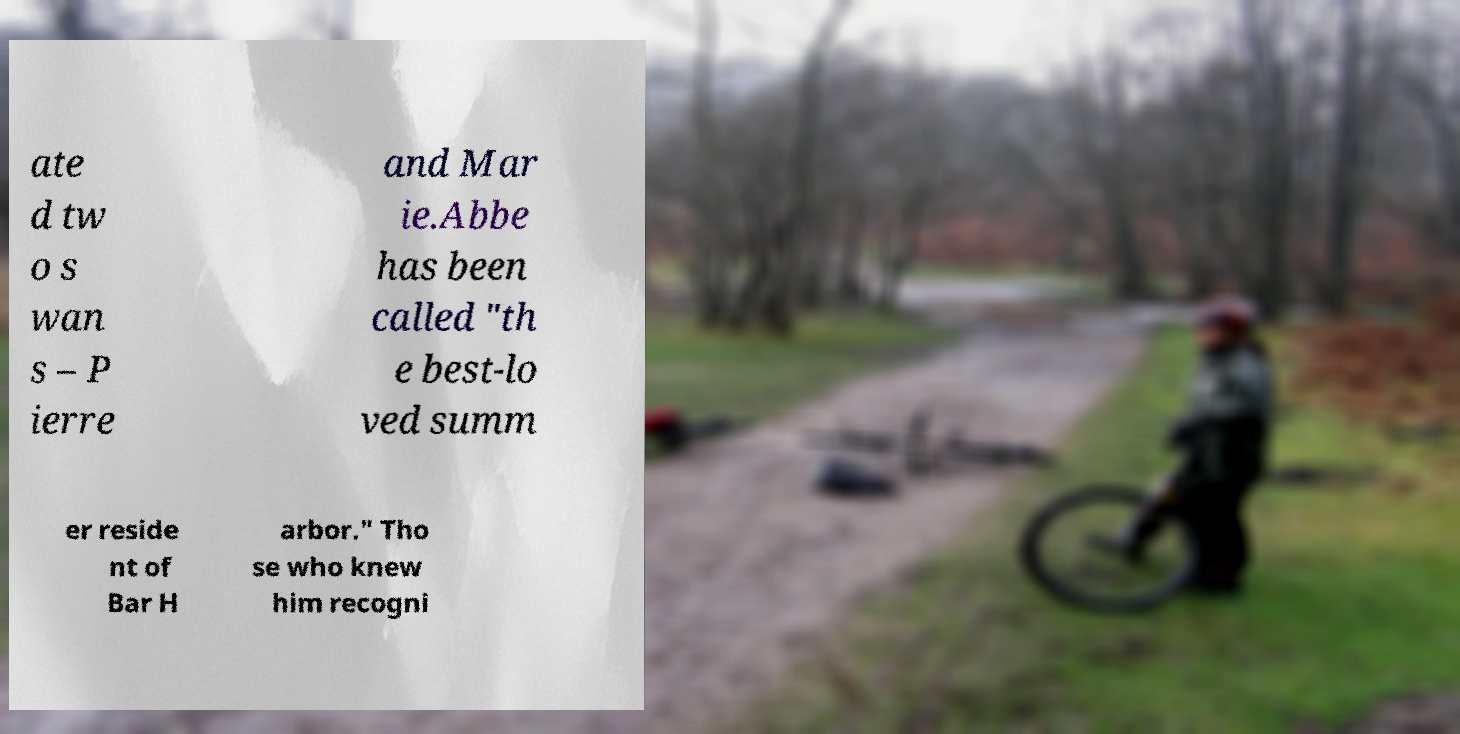Can you read and provide the text displayed in the image?This photo seems to have some interesting text. Can you extract and type it out for me? ate d tw o s wan s – P ierre and Mar ie.Abbe has been called "th e best-lo ved summ er reside nt of Bar H arbor." Tho se who knew him recogni 